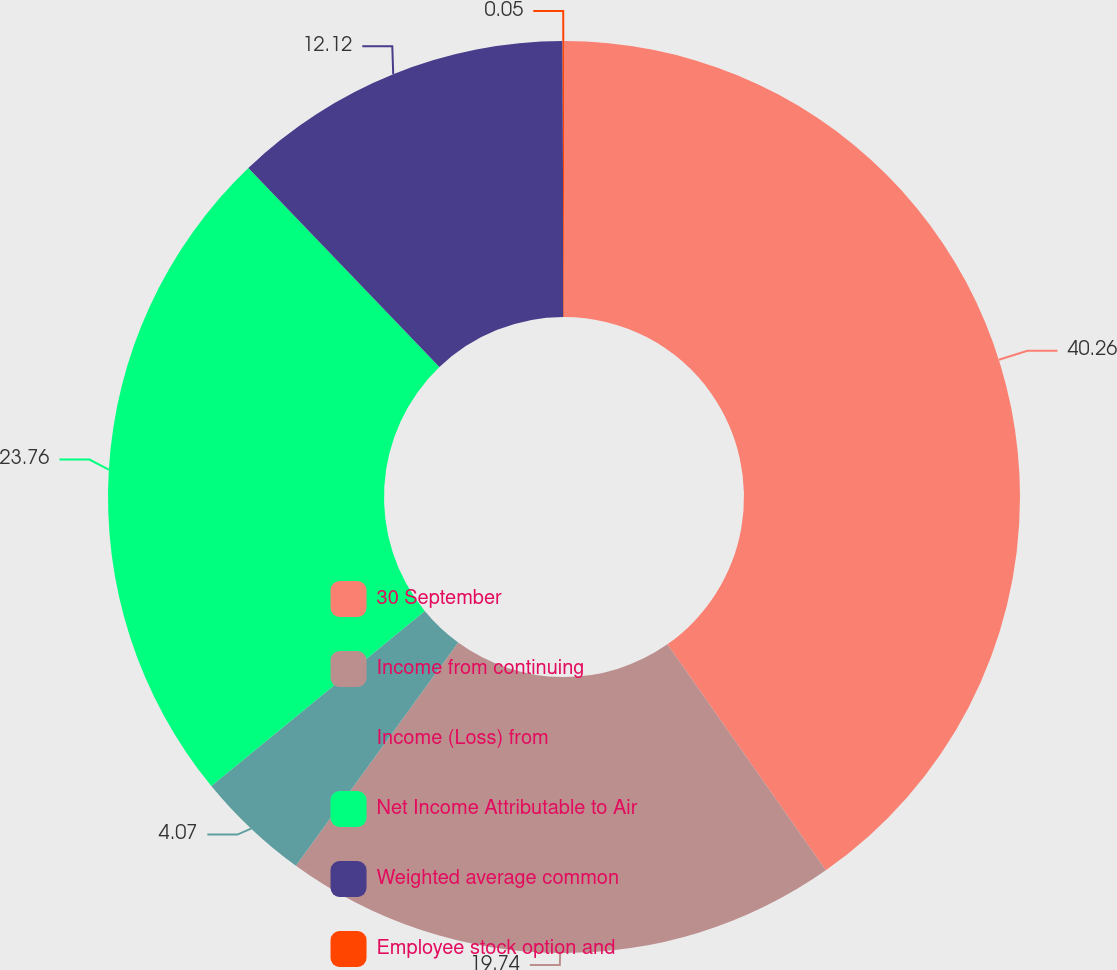Convert chart to OTSL. <chart><loc_0><loc_0><loc_500><loc_500><pie_chart><fcel>30 September<fcel>Income from continuing<fcel>Income (Loss) from<fcel>Net Income Attributable to Air<fcel>Weighted average common<fcel>Employee stock option and<nl><fcel>40.27%<fcel>19.74%<fcel>4.07%<fcel>23.76%<fcel>12.12%<fcel>0.05%<nl></chart> 